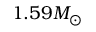Convert formula to latex. <formula><loc_0><loc_0><loc_500><loc_500>1 . 5 9 M _ { \odot }</formula> 